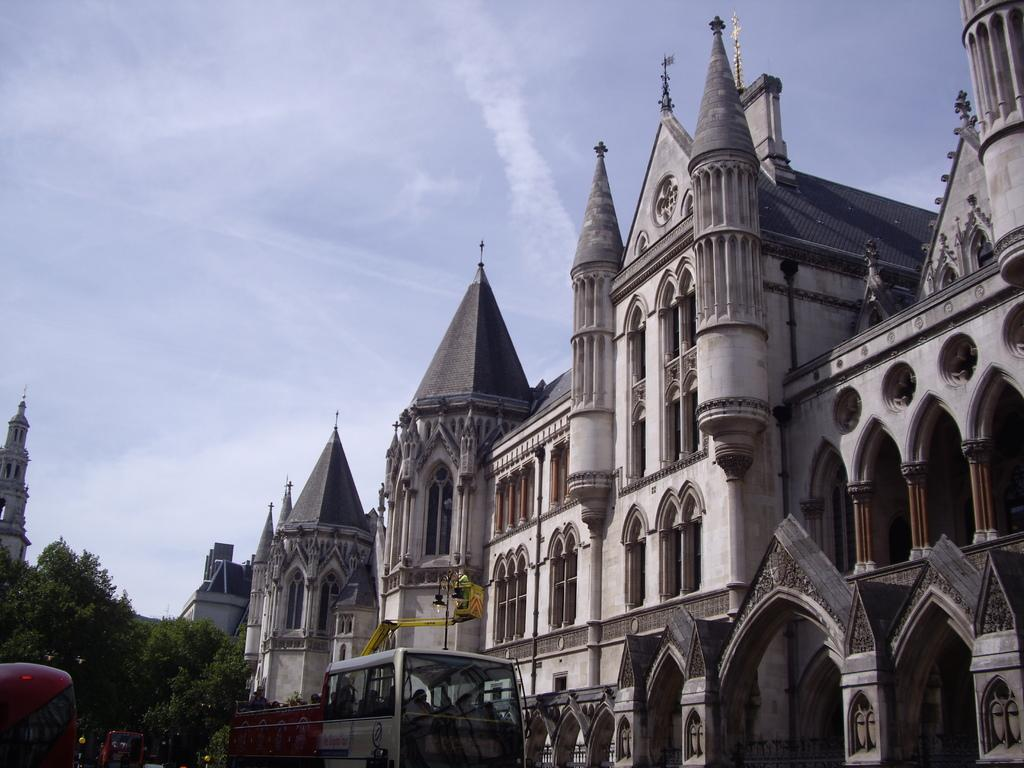What type of structures are visible in the image? There is a group of buildings in the image. What features can be observed on the buildings? The buildings have windows and pillars. What else can be seen in the image besides the buildings? There is a vehicle, a street lamp, a crane, and a group of trees in the image. What is the condition of the sky in the image? The sky is visible in the image and appears cloudy. What type of acoustics can be heard from the train in the image? There is no train present in the image, so it is not possible to determine the acoustics. 